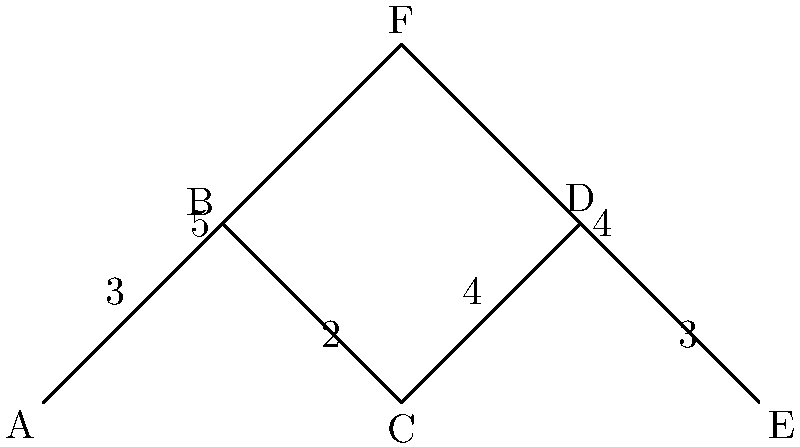In your wrestling gym, you want to arrange six practice stations (A, B, C, D, E, and F) to minimize transition time between exercises. The diagram shows the layout of the stations and the time (in seconds) it takes to move between connected stations. What is the minimum total time required to visit all stations exactly once, starting and ending at station A? To find the minimum total time, we need to find the shortest Hamiltonian cycle in this graph. Here's a step-by-step approach:

1) First, let's list all possible Hamiltonian cycles starting and ending at A:
   - A-B-C-D-E-F-A
   - A-B-C-D-E-F-A
   - A-F-E-D-C-B-A
   - A-F-B-C-D-E-A

2) Now, let's calculate the total time for each cycle:
   - A-B-C-D-E-F-A: 3 + 2 + 4 + 3 + 4 + 5 = 21 seconds
   - A-B-C-D-E-F-A: 3 + 2 + 4 + 3 + 4 + 5 = 21 seconds (same as the first)
   - A-F-E-D-C-B-A: 5 + 4 + 3 + 4 + 2 + 3 = 21 seconds
   - A-F-B-C-D-E-A: 5 + 3 + 2 + 4 + 3 + 4 = 21 seconds

3) We can see that all cycles have the same total time of 21 seconds.

4) Therefore, the minimum total time required to visit all stations exactly once, starting and ending at station A, is 21 seconds.

This result shows that regardless of the order in which you visit the stations, the total transition time remains the same. This property is characteristic of certain graph structures and can be useful in optimizing workout routines.
Answer: 21 seconds 